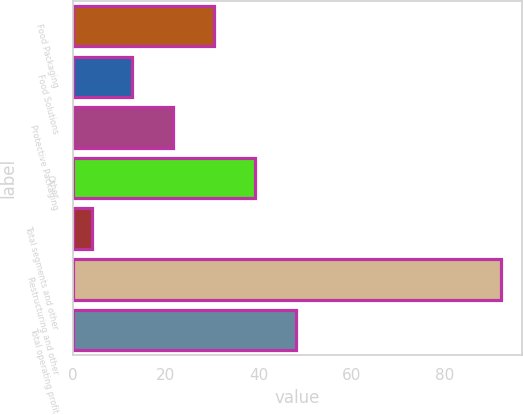Convert chart to OTSL. <chart><loc_0><loc_0><loc_500><loc_500><bar_chart><fcel>Food Packaging<fcel>Food Solutions<fcel>Protective Packaging<fcel>Other<fcel>Total segments and other<fcel>Restructuring and other<fcel>Total operating profit<nl><fcel>30.4<fcel>12.8<fcel>21.6<fcel>39.2<fcel>4<fcel>92<fcel>48<nl></chart> 